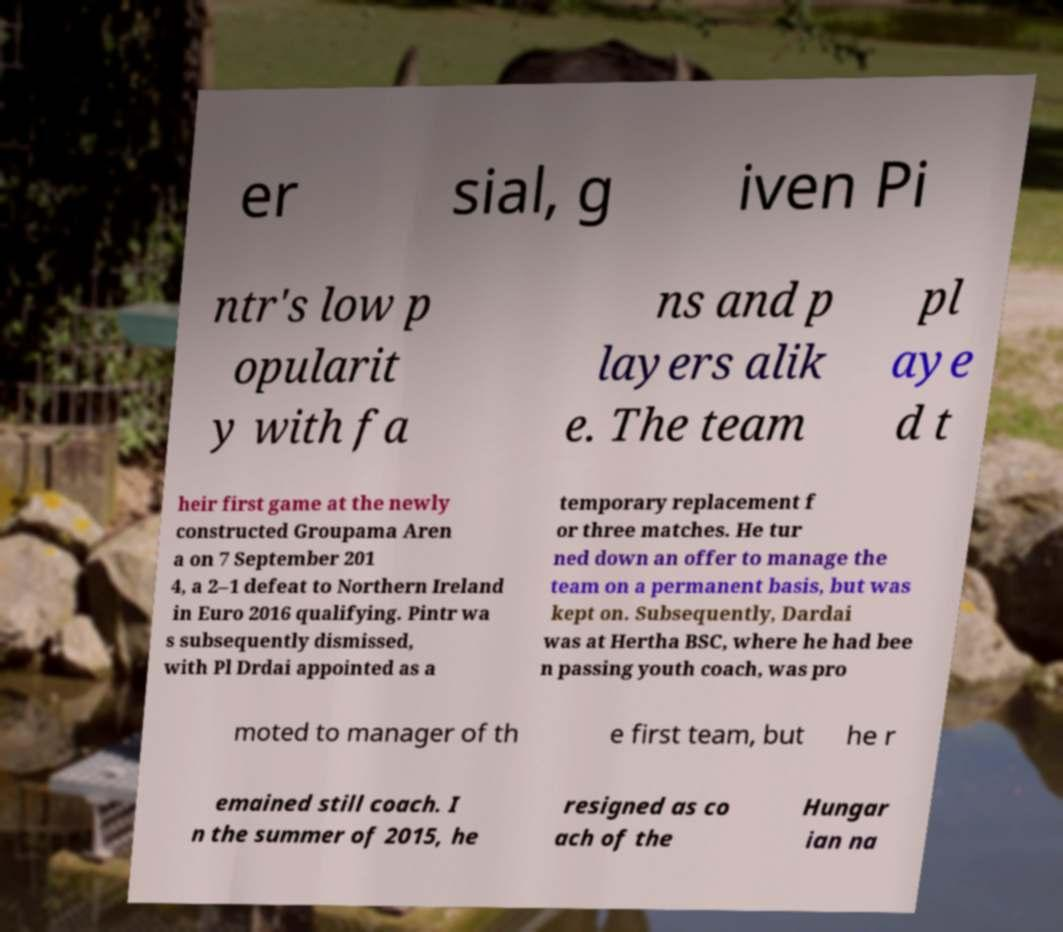Can you accurately transcribe the text from the provided image for me? er sial, g iven Pi ntr's low p opularit y with fa ns and p layers alik e. The team pl aye d t heir first game at the newly constructed Groupama Aren a on 7 September 201 4, a 2–1 defeat to Northern Ireland in Euro 2016 qualifying. Pintr wa s subsequently dismissed, with Pl Drdai appointed as a temporary replacement f or three matches. He tur ned down an offer to manage the team on a permanent basis, but was kept on. Subsequently, Dardai was at Hertha BSC, where he had bee n passing youth coach, was pro moted to manager of th e first team, but he r emained still coach. I n the summer of 2015, he resigned as co ach of the Hungar ian na 